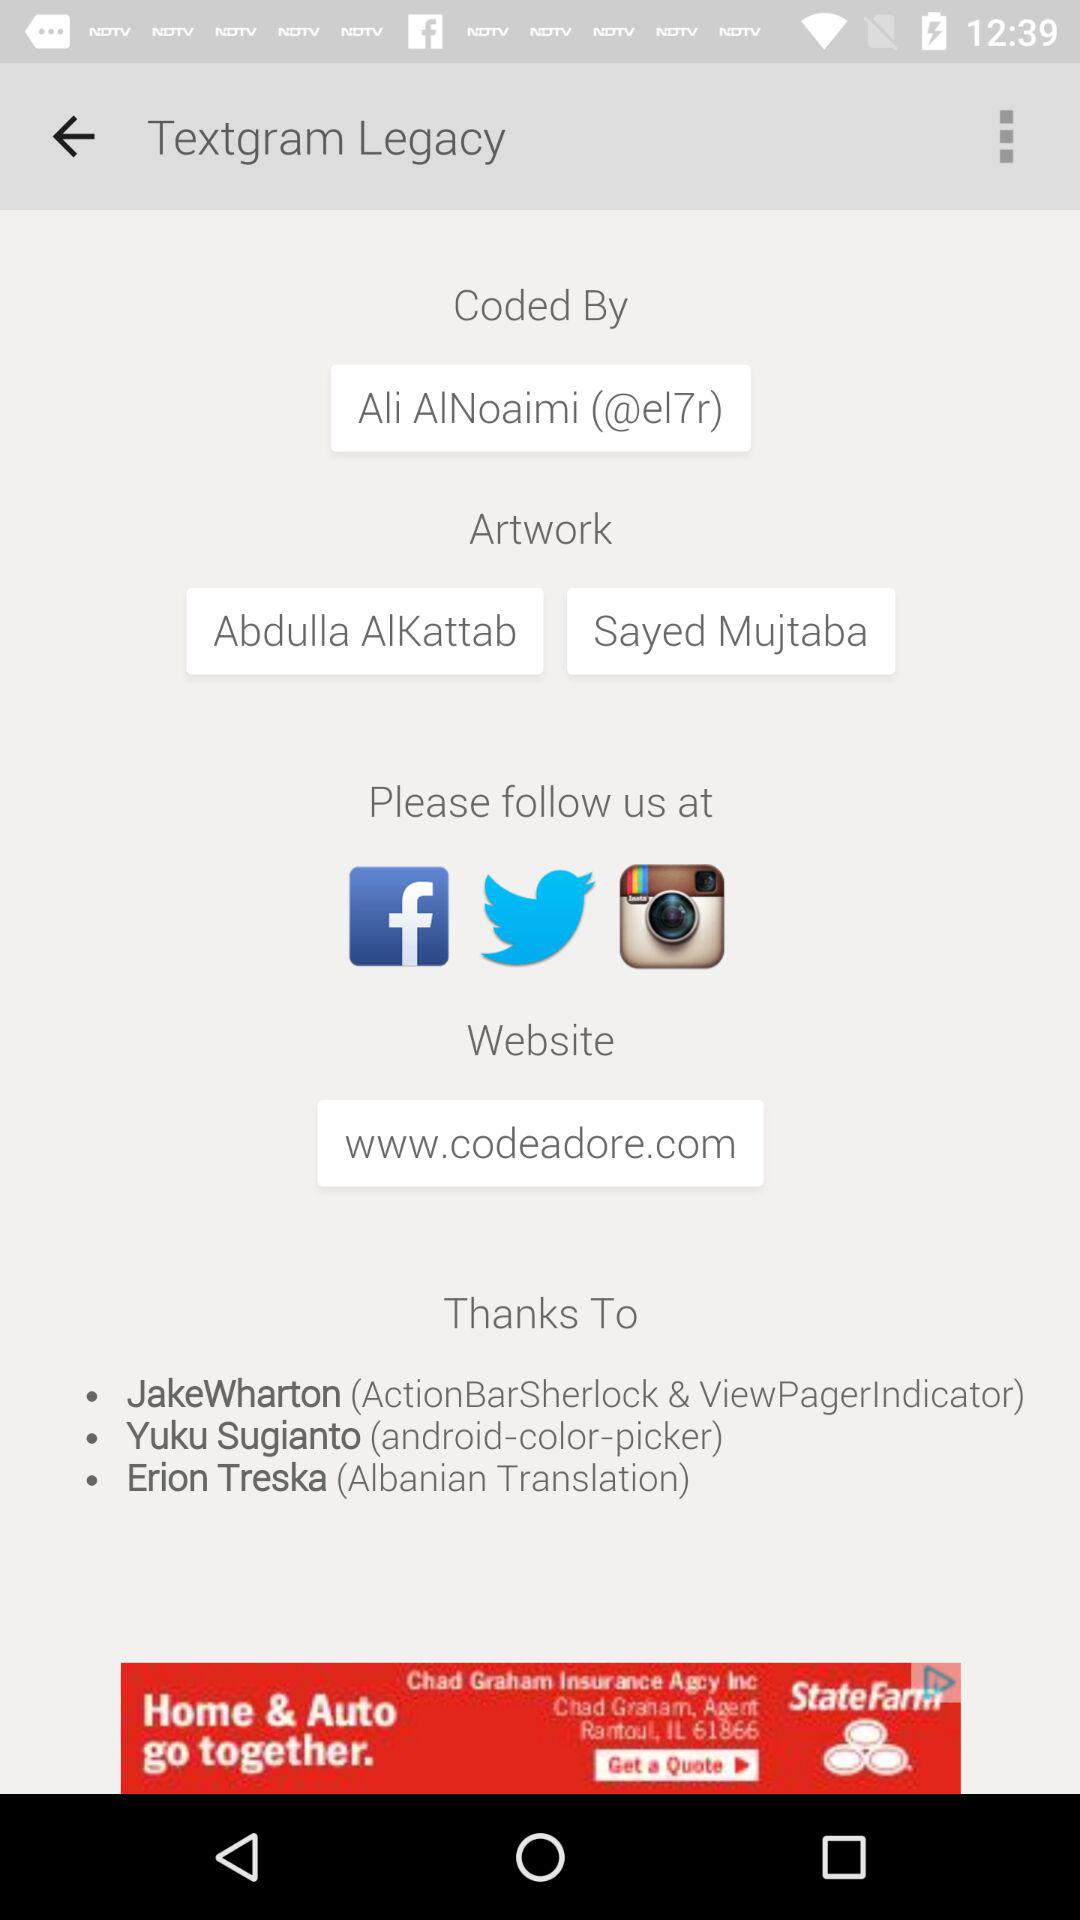What is the website? The website is www.codeadore.com. 